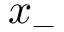<formula> <loc_0><loc_0><loc_500><loc_500>x _ { - }</formula> 